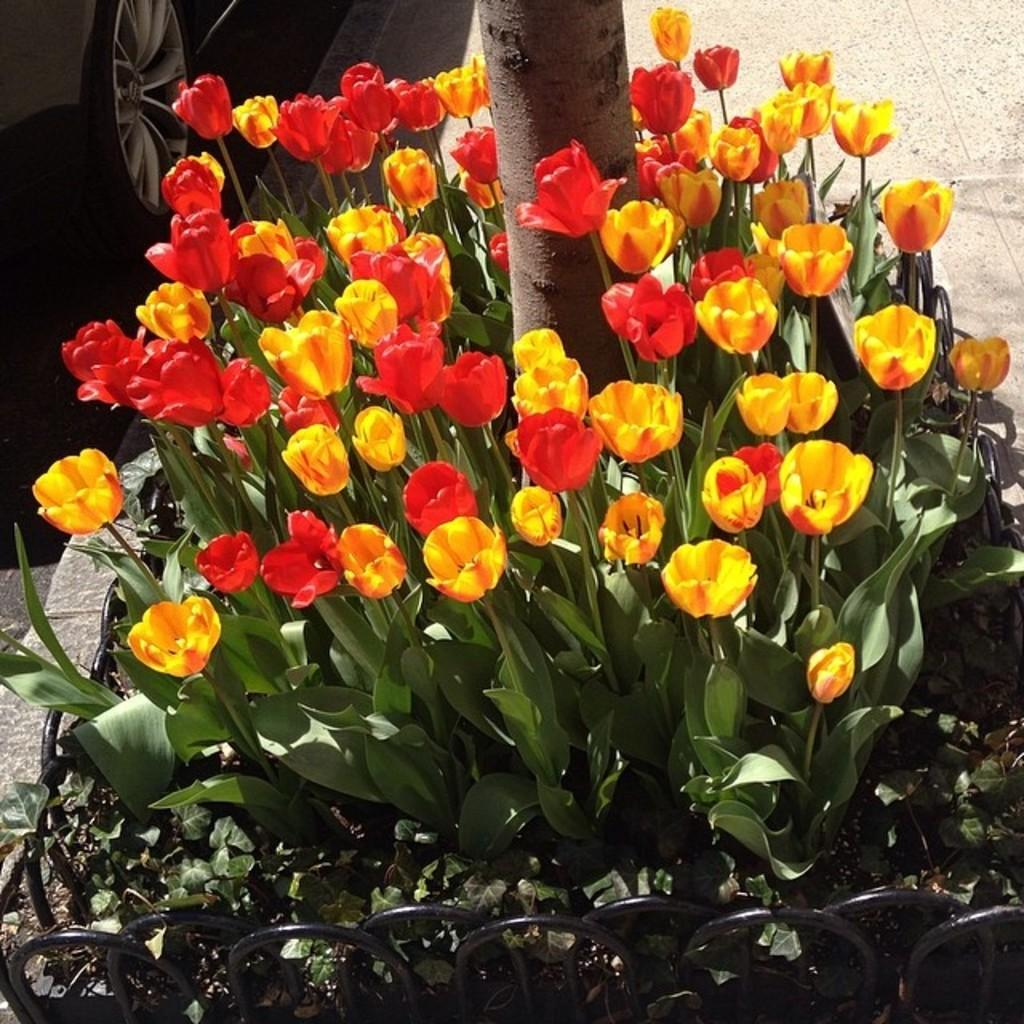What type of flora is present in the image? There are beautiful flowers in the image. Can you describe the tree trunk in the image? The tree trunk is located among the flowers. Where is the vehicle positioned in the image? The vehicle is on the left side of the image. How many tomatoes can be seen growing on the tree trunk in the image? There are no tomatoes present in the image, as it features flowers and a tree trunk. 